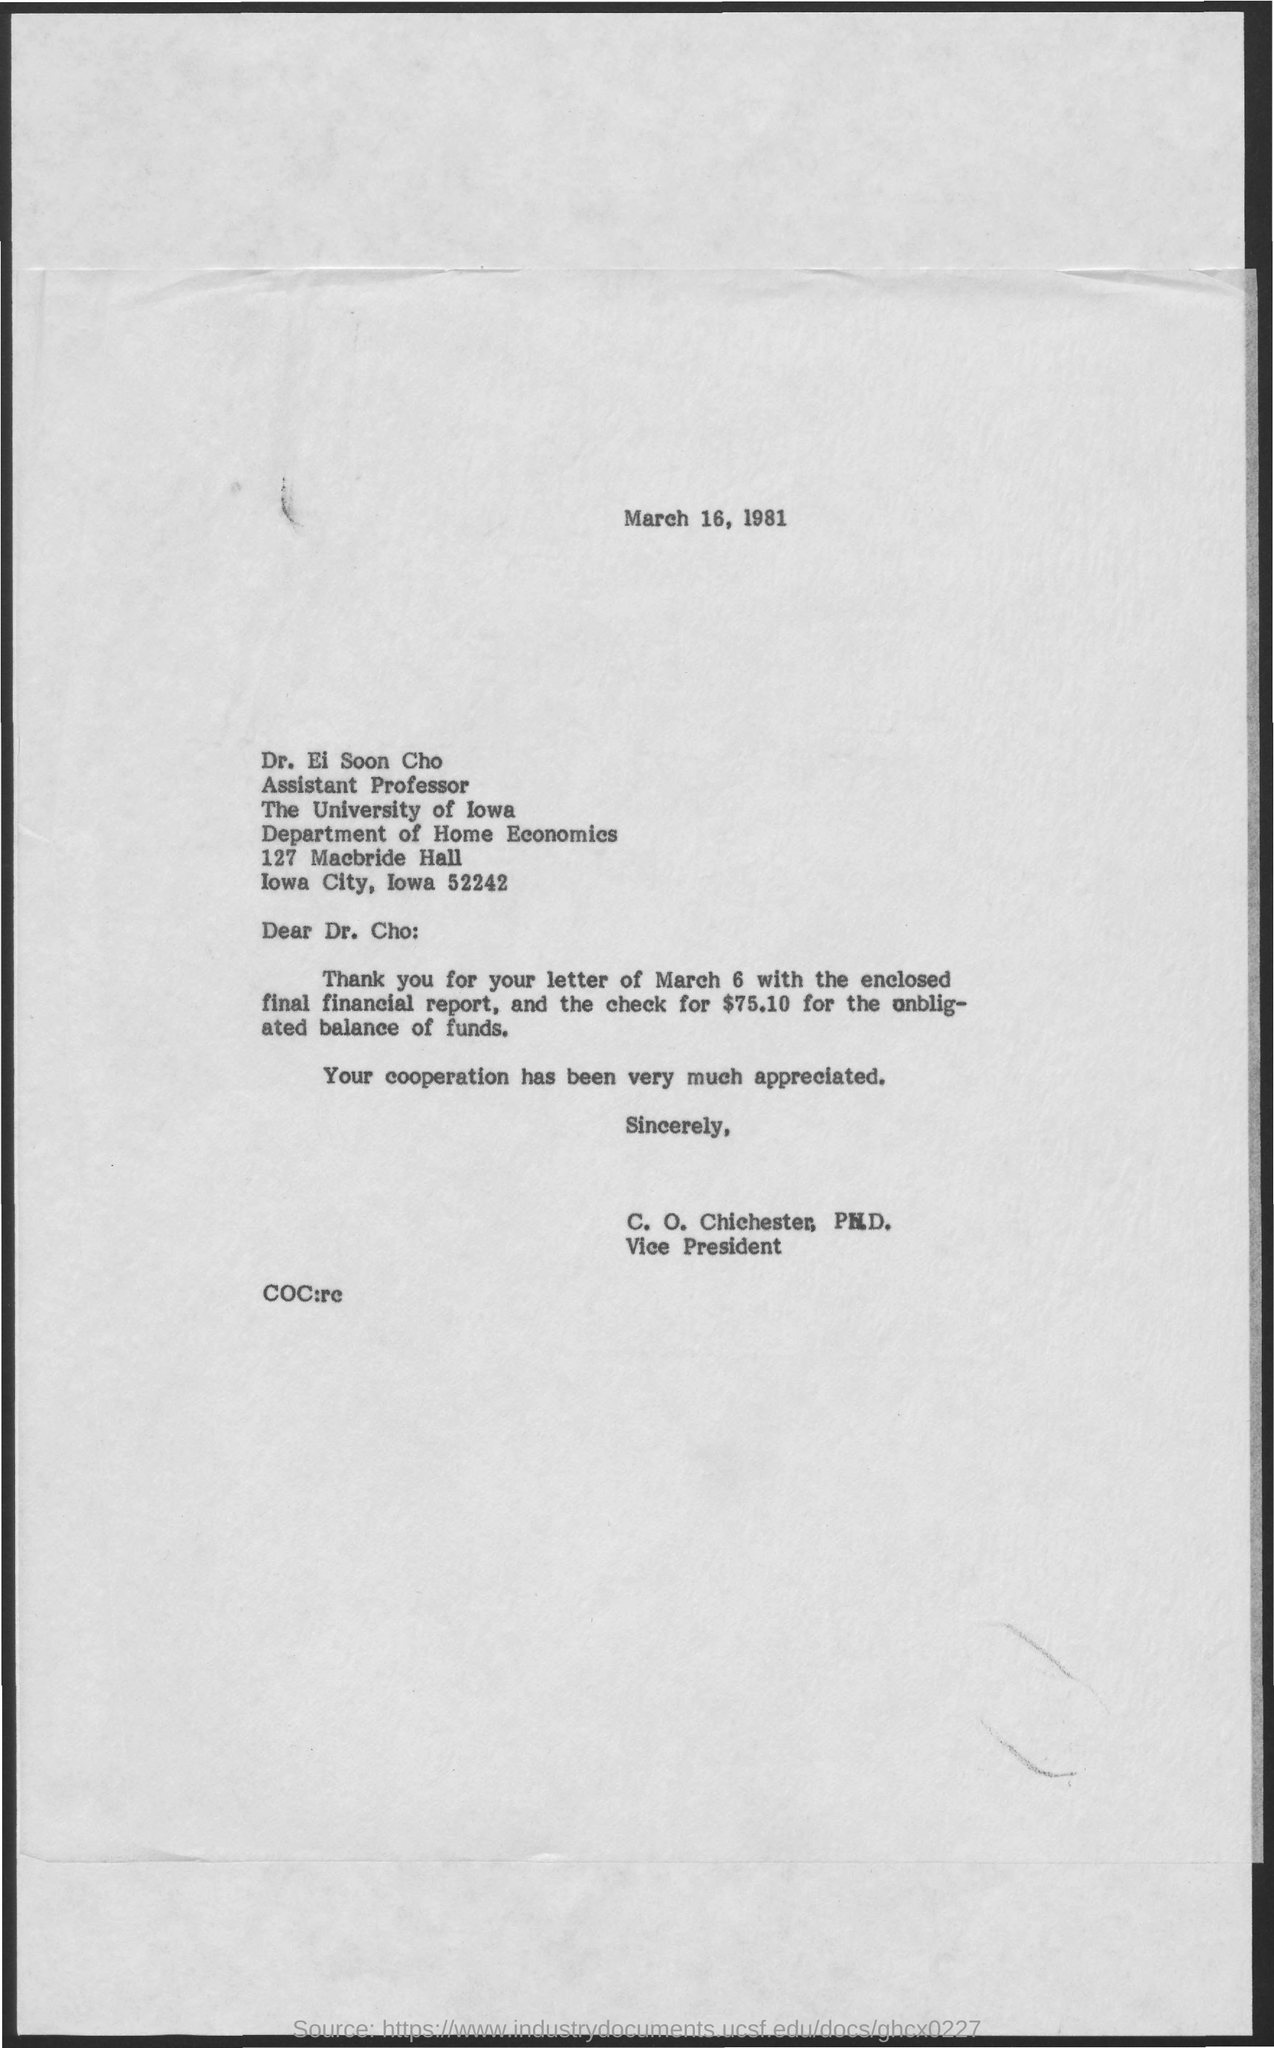What is the date on the document?
Keep it short and to the point. March 16, 1981. To Whom is this letter addressed to?
Your answer should be compact. Dr. Ei Soon Cho. Who is this letter from?
Give a very brief answer. C. O. Chichester, Ph.D. How much is the check amount?
Give a very brief answer. $75.10. 